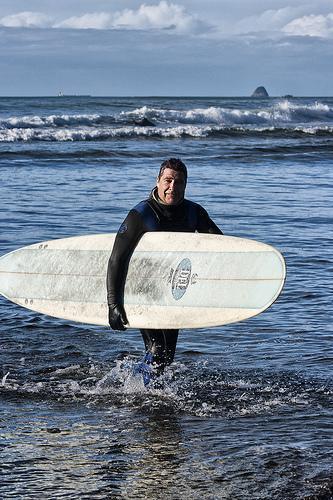How many people are in the photo?
Give a very brief answer. 1. 